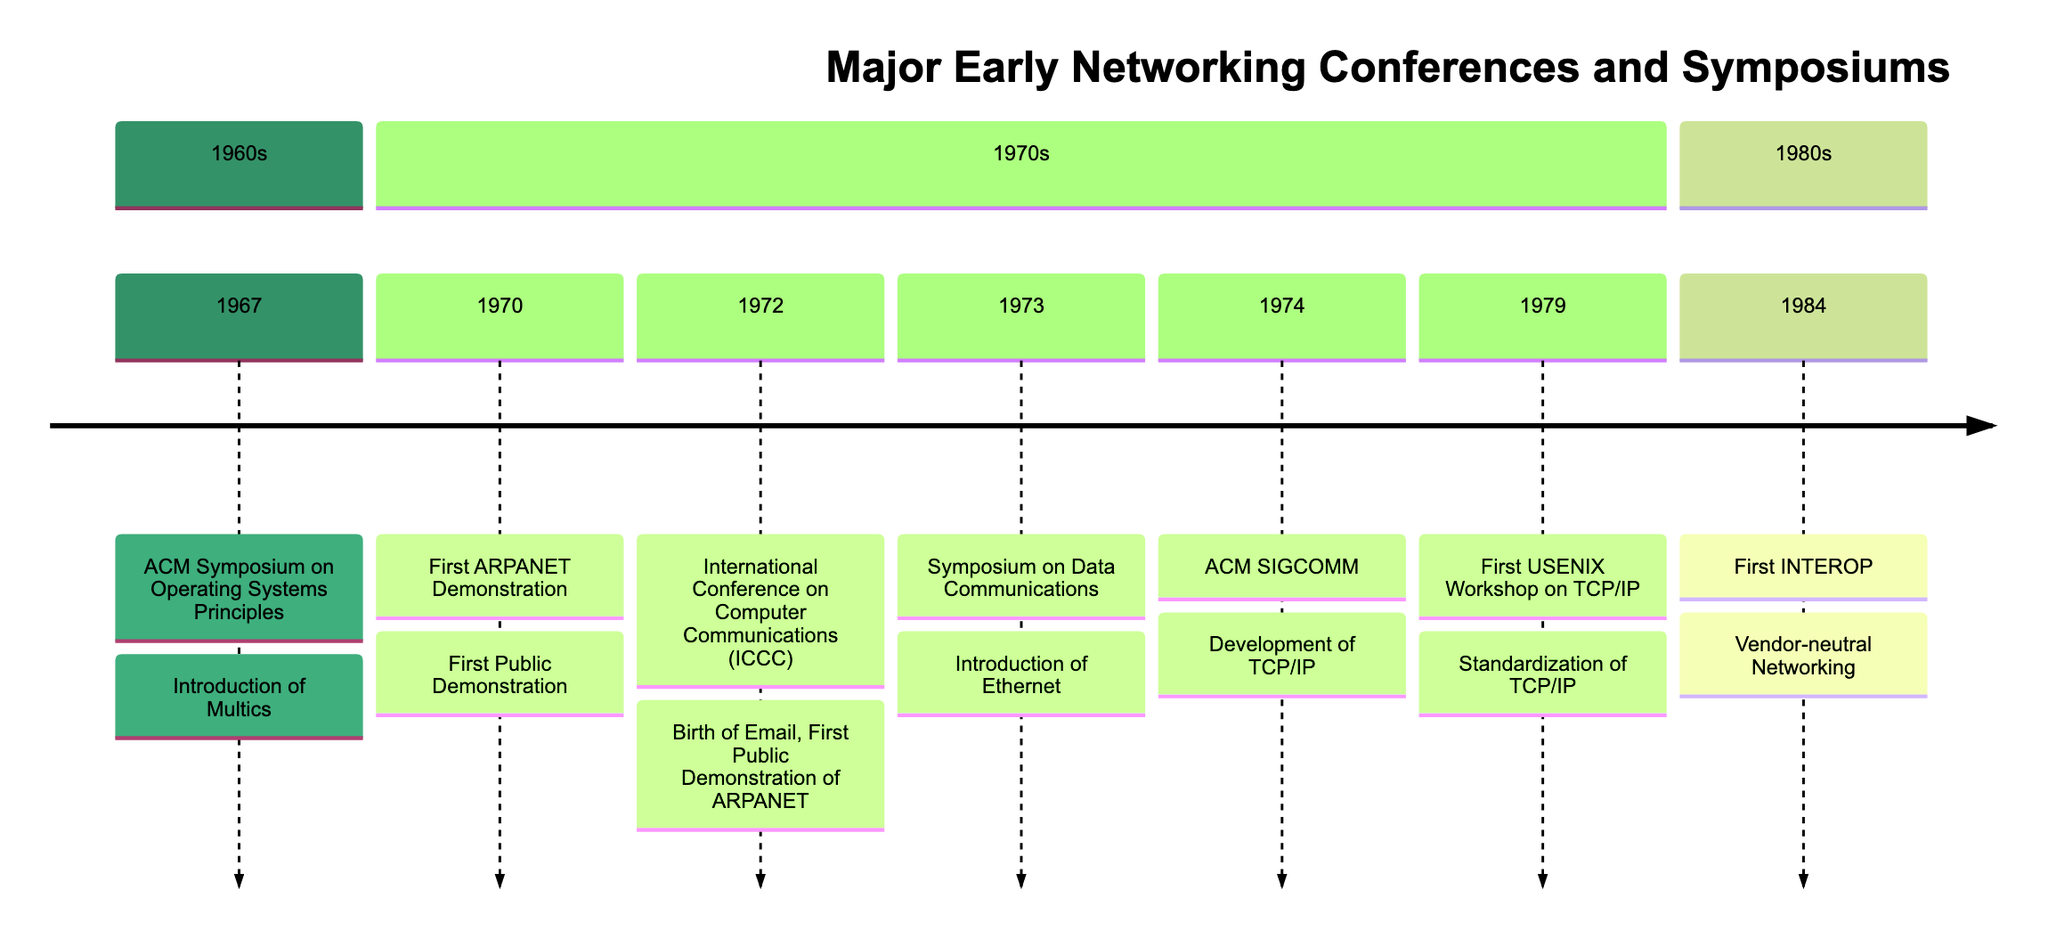What is the first conference listed in the timeline? The timeline starts with the ACM Symposium on Operating Systems Principles, which is the earliest event shown.
Answer: ACM Symposium on Operating Systems Principles How many events occurred in the 1970s? By counting the listed events, there are five total events presented in the 1970s section of the timeline.
Answer: 5 What was introduced at the 1973 Symposium on Data Communications? The event highlighted the introduction of Ethernet, presented by Robert Metcalfe, which is mentioned in the contributions for that date.
Answer: Introduction of Ethernet Which conference in the timeline took place in Washington, D.C.? Two conferences are shown to have taken place in Washington, D.C., as per the timeline: the First ARPANET Demonstration and the International Conference on Computer Communications.
Answer: First ARPANET Demonstration, International Conference on Computer Communications What is the significance of the 1984 INTEROP event? The 1984 INTEROP event is significant for providing a platform for interoperability testing among different vendors, which is crucial for networking.
Answer: Vendor-neutral Networking Which contribution mentioned in the diagram relates to email? The birth of Email, presented by Ray Tomlinson at the International Conference on Computer Communications on October 24, 1972, describes the introduction of electronic mail.
Answer: Birth of Email How many contributions are listed for the 1972 ICCC event? There are two contributions noted for the International Conference on Computer Communications: the birth of Email and the first public demonstration of ARPANET, leading to a total of two contributions for this event.
Answer: 2 What was the focus of the First USENIX Workshop on TCP/IP? The focus of the First USENIX Workshop was on standardization of TCP/IP, which is clearly stated in the listed contributions of the event.
Answer: Standardization of TCP/IP 